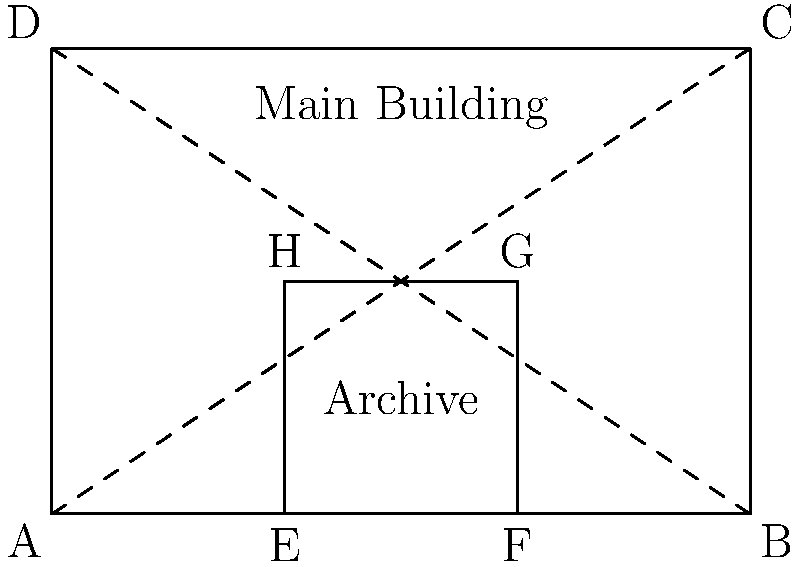A historical research institute is planning to construct a new archive within its main building. The main building is rectangular with dimensions 6 units by 4 units. The proposed archive is also rectangular and occupies one-third of the main building's area, positioned in the bottom-right corner as shown in the diagram. If the diagonal of the main building is $\sqrt{52}$ units long, what is the length of the diagonal of the archive in units? Let's approach this step-by-step:

1) First, we need to confirm the dimensions of the main building. We're told it's 6 units by 4 units, and the diagonal is $\sqrt{52}$ units. Let's verify this using the Pythagorean theorem:

   $diagonal^2 = 6^2 + 4^2 = 36 + 16 = 52$
   $diagonal = \sqrt{52}$

   This confirms the given information.

2) Now, we're told the archive occupies one-third of the main building's area. Let's calculate this:

   Area of main building = $6 * 4 = 24$ square units
   Area of archive = $24 / 3 = 8$ square units

3) We can see from the diagram that the archive is 2 units by 4 units, which indeed gives an area of 8 square units.

4) To find the diagonal of the archive, we can again use the Pythagorean theorem:

   $diagonal^2 = 2^2 + 4^2 = 4 + 16 = 20$
   $diagonal = \sqrt{20} = 2\sqrt{5}$

Therefore, the diagonal of the archive is $2\sqrt{5}$ units long.
Answer: $2\sqrt{5}$ units 